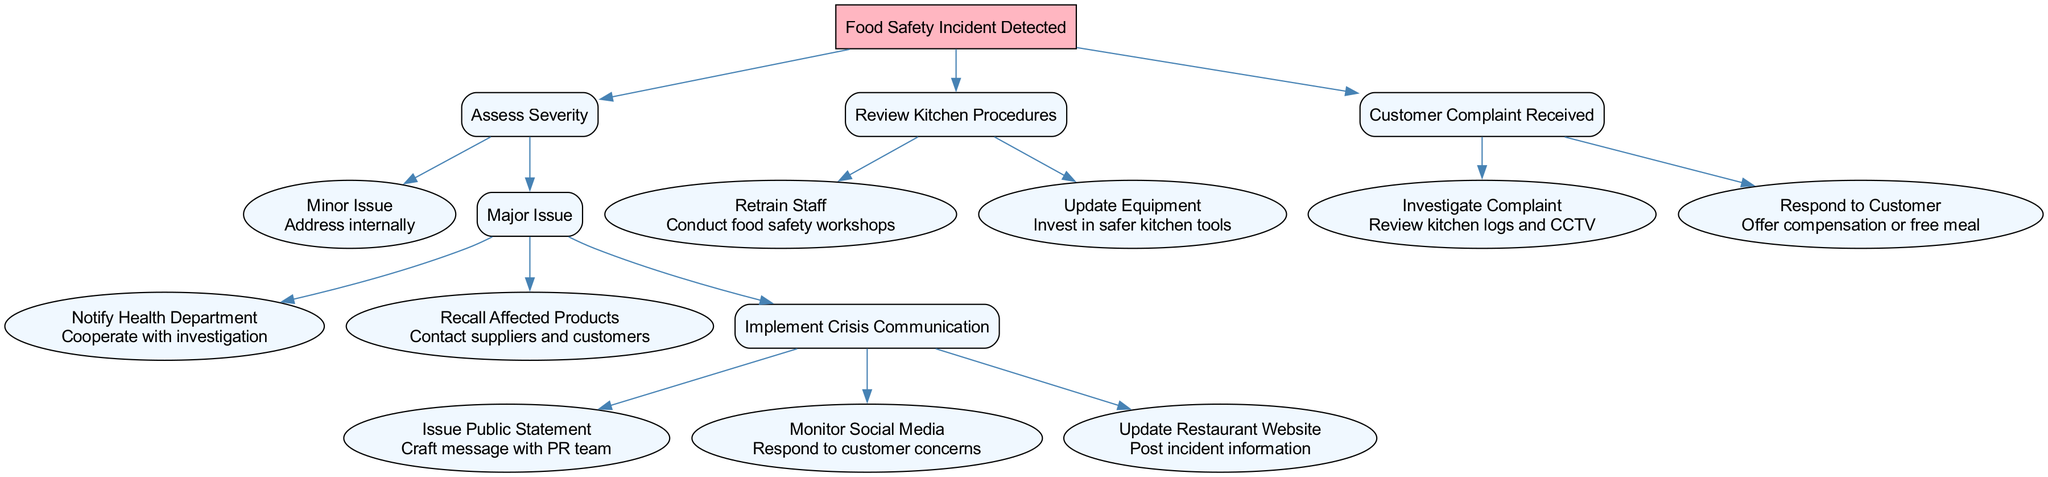What is the root node of the decision tree? The root node is represented at the top of the diagram and indicates the central issue being addressed. In this case, the root node is "Food Safety Incident Detected".
Answer: Food Safety Incident Detected How many branches are under the root node? The number of branches can be counted by checking the main divisions originating from the root. There are three main branches: Assess Severity, Review Kitchen Procedures, and Customer Complaint Received.
Answer: 3 What action is taken for a minor issue? Following the path from the "Minor Issue" node leads directly to its associated action. The action specified under this node is "Address internally".
Answer: Address internally What do we do after a major issue is assessed? The flow from the "Major Issue" node outlines several actions. We must first look at the node's children, which include Notify Health Department, Recall Affected Products, and Implement Crisis Communication. Thus, the response depends on the steps taken thereafter.
Answer: Notify Health Department, Recall Affected Products, Implement Crisis Communication What is one action that can be taken to respond to customer complaints? A direct branch under the "Customer Complaint Received" node lists two actions we can undertake. One of them is to "Offer compensation or free meal".
Answer: Offer compensation or free meal What node follows the action "Implement Crisis Communication"? To determine the next step after "Implement Crisis Communication", we can examine its children nodes. The immediate actions that follow are: Issue Public Statement, Monitor Social Media, and Update Restaurant Website.
Answer: Issue Public Statement, Monitor Social Media, Update Restaurant Website What must be done when a food safety incident is detected? The root nodes lead us to assess severity first, implying that this is the crucial initial step for addressing food safety incidents.
Answer: Assess Severity What is the connection between "Recall Affected Products" and "Notify Health Department"? Both of these nodes are children of the "Major Issue" node, indicating that they are actions taken in parallel as responses to the same type of incident.
Answer: Both are actions under Major Issue 